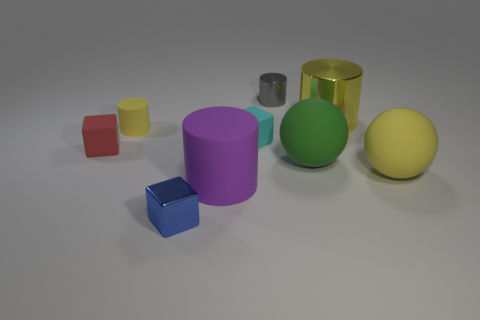What size is the cylinder that is the same color as the large shiny object?
Make the answer very short. Small. Does the big metallic cylinder have the same color as the small matte cylinder?
Your answer should be very brief. Yes. There is a tiny cylinder that is the same color as the big metal thing; what material is it?
Offer a terse response. Rubber. Is the number of big yellow cylinders greater than the number of tiny gray metallic cubes?
Offer a very short reply. Yes. Is the size of the blue thing the same as the green rubber thing?
Give a very brief answer. No. How many objects are cubes or small blue metal things?
Make the answer very short. 3. The shiny object in front of the matte cylinder in front of the cube that is left of the blue block is what shape?
Give a very brief answer. Cube. Do the large thing that is behind the small cyan thing and the large ball that is behind the large yellow rubber object have the same material?
Your response must be concise. No. There is another object that is the same shape as the large yellow rubber thing; what is its material?
Offer a very short reply. Rubber. Are there any other things that are the same size as the yellow rubber cylinder?
Your answer should be compact. Yes. 